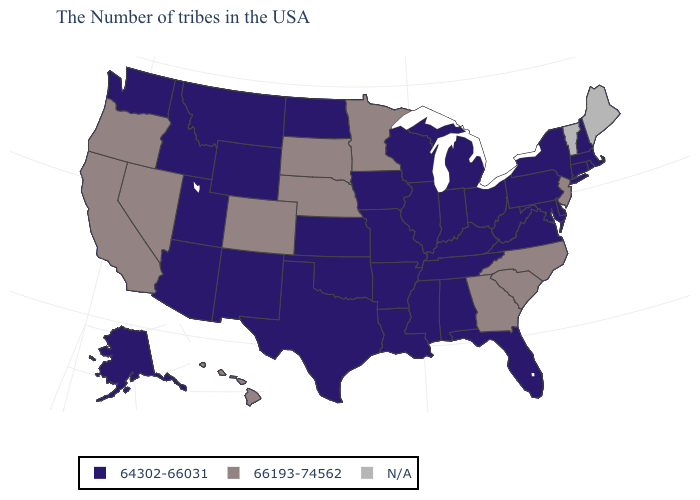What is the highest value in the MidWest ?
Answer briefly. 66193-74562. What is the value of Nebraska?
Write a very short answer. 66193-74562. Does Idaho have the lowest value in the USA?
Keep it brief. Yes. Name the states that have a value in the range N/A?
Short answer required. Maine, Vermont. What is the highest value in states that border New York?
Short answer required. 66193-74562. What is the value of Arkansas?
Give a very brief answer. 64302-66031. Name the states that have a value in the range N/A?
Answer briefly. Maine, Vermont. Which states have the highest value in the USA?
Write a very short answer. New Jersey, North Carolina, South Carolina, Georgia, Minnesota, Nebraska, South Dakota, Colorado, Nevada, California, Oregon, Hawaii. Name the states that have a value in the range 66193-74562?
Keep it brief. New Jersey, North Carolina, South Carolina, Georgia, Minnesota, Nebraska, South Dakota, Colorado, Nevada, California, Oregon, Hawaii. Name the states that have a value in the range 64302-66031?
Keep it brief. Massachusetts, Rhode Island, New Hampshire, Connecticut, New York, Delaware, Maryland, Pennsylvania, Virginia, West Virginia, Ohio, Florida, Michigan, Kentucky, Indiana, Alabama, Tennessee, Wisconsin, Illinois, Mississippi, Louisiana, Missouri, Arkansas, Iowa, Kansas, Oklahoma, Texas, North Dakota, Wyoming, New Mexico, Utah, Montana, Arizona, Idaho, Washington, Alaska. Among the states that border Florida , does Georgia have the highest value?
Quick response, please. Yes. Does Pennsylvania have the highest value in the Northeast?
Quick response, please. No. Among the states that border Nebraska , does Iowa have the highest value?
Concise answer only. No. Name the states that have a value in the range 66193-74562?
Concise answer only. New Jersey, North Carolina, South Carolina, Georgia, Minnesota, Nebraska, South Dakota, Colorado, Nevada, California, Oregon, Hawaii. 